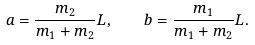<formula> <loc_0><loc_0><loc_500><loc_500>a = \frac { m _ { 2 } } { m _ { 1 } + m _ { 2 } } L , \quad b = \frac { m _ { 1 } } { m _ { 1 } + m _ { 2 } } L .</formula> 